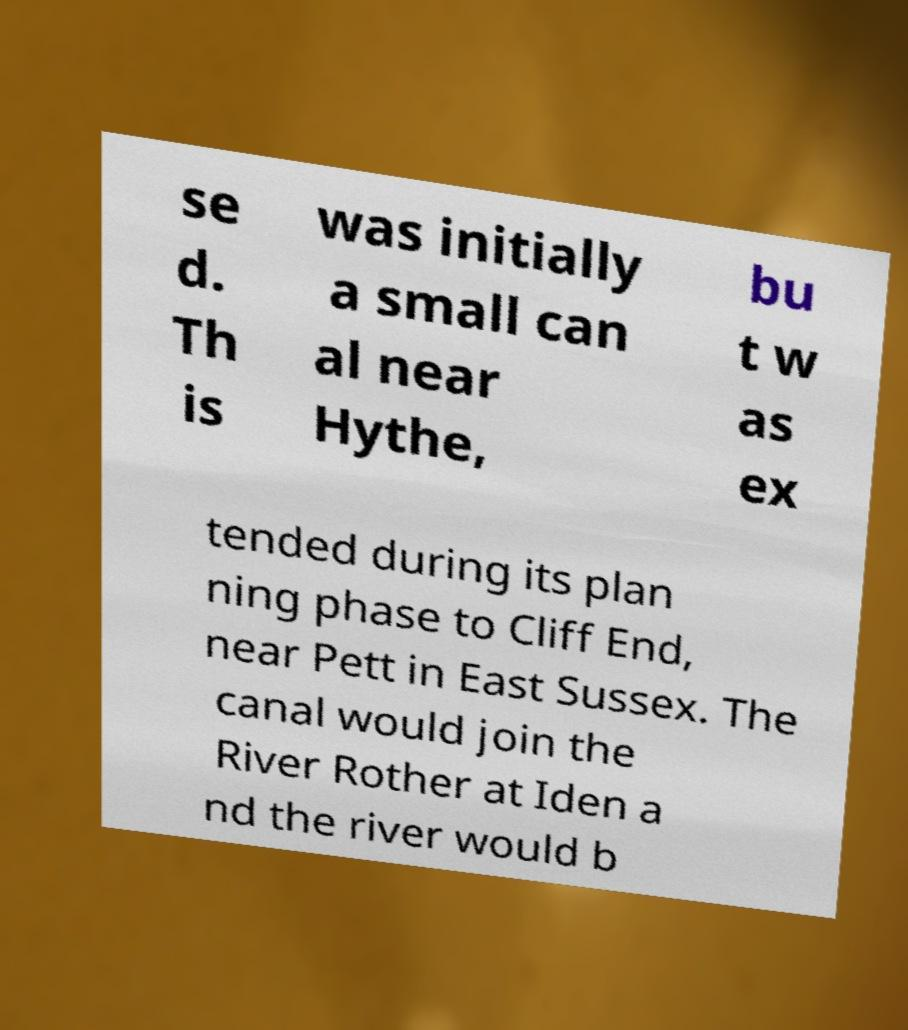Can you accurately transcribe the text from the provided image for me? se d. Th is was initially a small can al near Hythe, bu t w as ex tended during its plan ning phase to Cliff End, near Pett in East Sussex. The canal would join the River Rother at Iden a nd the river would b 